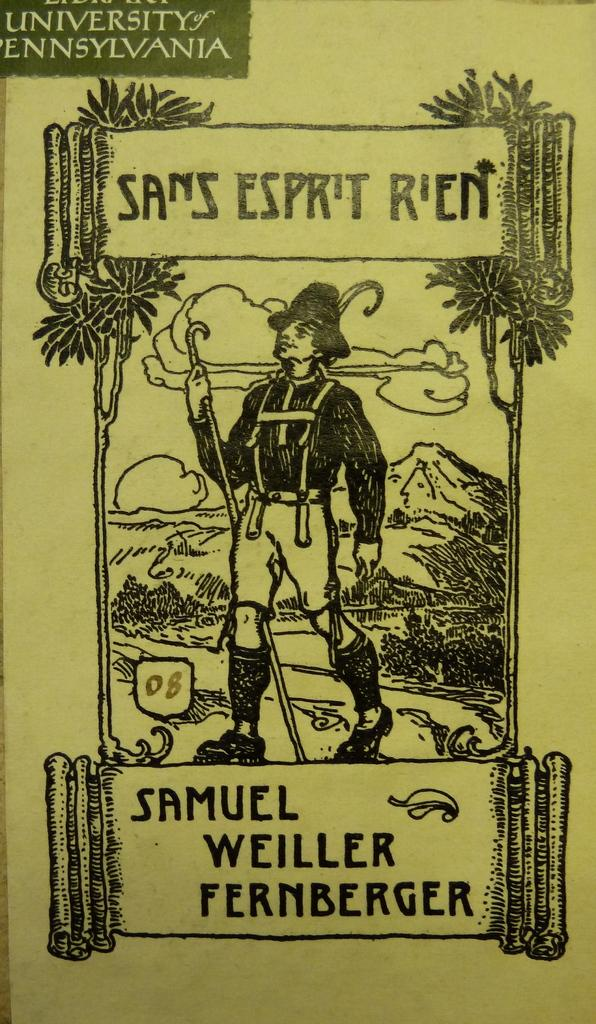<image>
Create a compact narrative representing the image presented. Poster showing a soldier and is from University of Pennsylvania. 